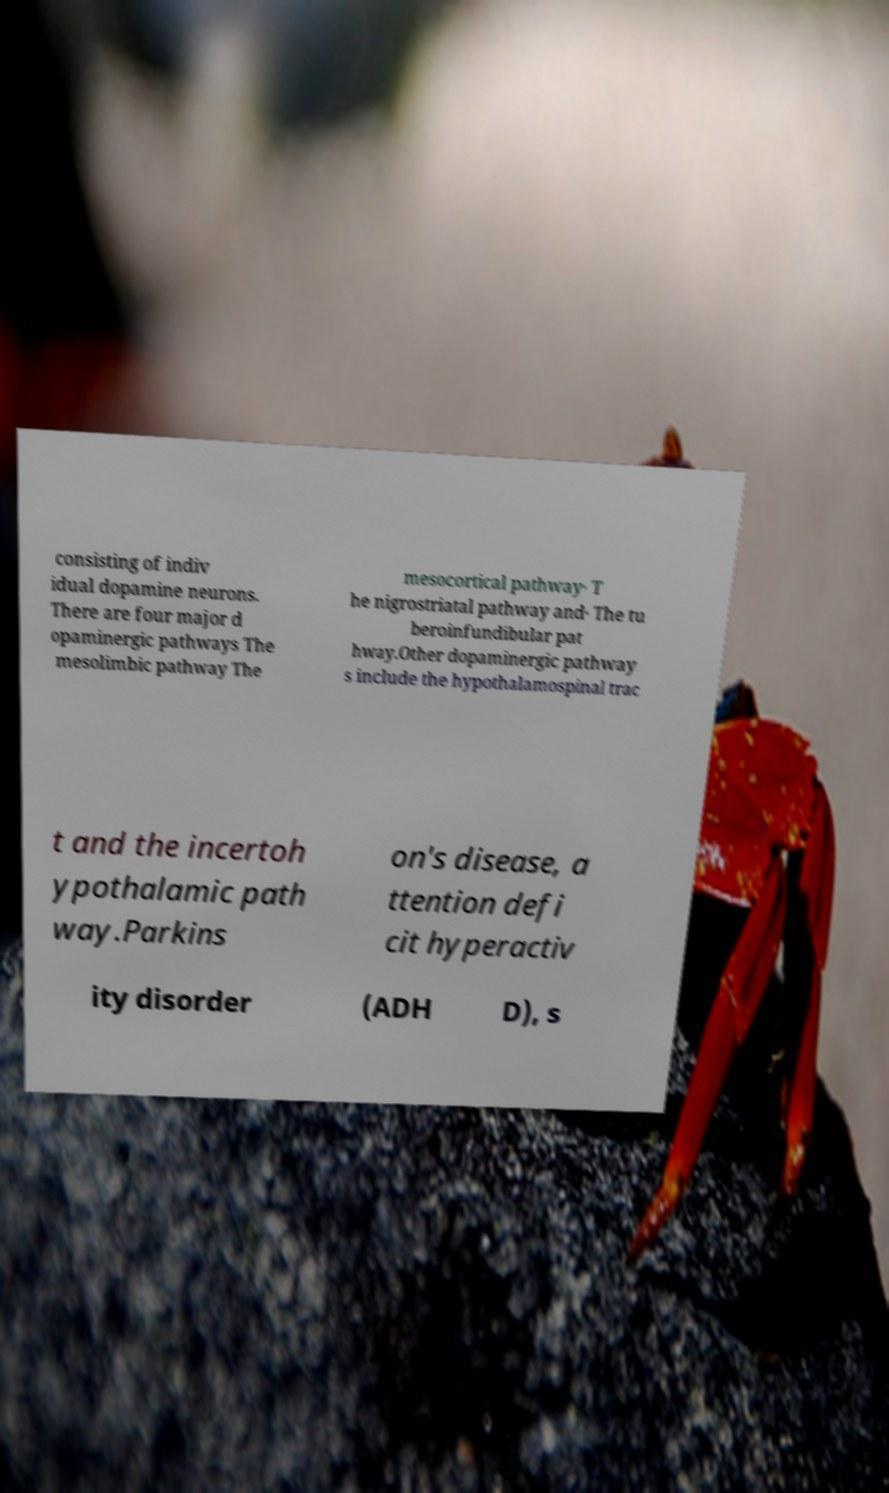Could you assist in decoding the text presented in this image and type it out clearly? consisting of indiv idual dopamine neurons. There are four major d opaminergic pathways The mesolimbic pathway The mesocortical pathway· T he nigrostriatal pathway and· The tu beroinfundibular pat hway.Other dopaminergic pathway s include the hypothalamospinal trac t and the incertoh ypothalamic path way.Parkins on's disease, a ttention defi cit hyperactiv ity disorder (ADH D), s 